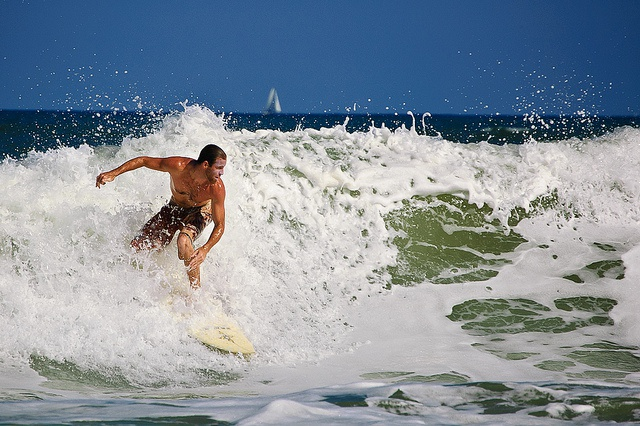Describe the objects in this image and their specific colors. I can see people in darkblue, maroon, black, brown, and lightgray tones and surfboard in darkblue, lightgray, tan, and darkgray tones in this image. 